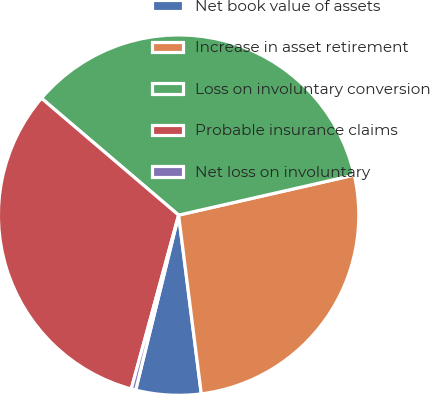<chart> <loc_0><loc_0><loc_500><loc_500><pie_chart><fcel>Net book value of assets<fcel>Increase in asset retirement<fcel>Loss on involuntary conversion<fcel>Probable insurance claims<fcel>Net loss on involuntary<nl><fcel>5.84%<fcel>26.56%<fcel>35.2%<fcel>32.0%<fcel>0.4%<nl></chart> 